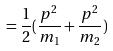<formula> <loc_0><loc_0><loc_500><loc_500>= \frac { 1 } { 2 } ( \frac { p ^ { 2 } } { m _ { 1 } } + \frac { p ^ { 2 } } { m _ { 2 } } )</formula> 